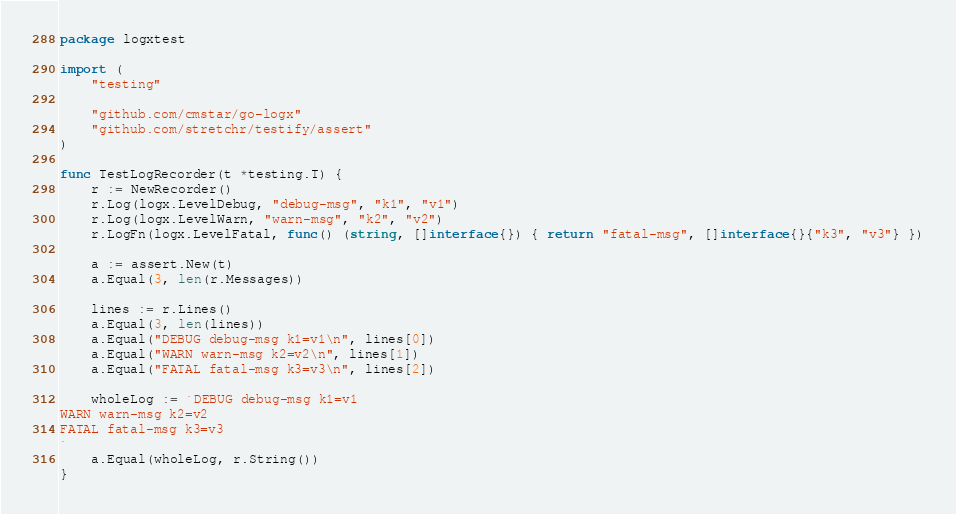<code> <loc_0><loc_0><loc_500><loc_500><_Go_>package logxtest

import (
	"testing"

	"github.com/cmstar/go-logx"
	"github.com/stretchr/testify/assert"
)

func TestLogRecorder(t *testing.T) {
	r := NewRecorder()
	r.Log(logx.LevelDebug, "debug-msg", "k1", "v1")
	r.Log(logx.LevelWarn, "warn-msg", "k2", "v2")
	r.LogFn(logx.LevelFatal, func() (string, []interface{}) { return "fatal-msg", []interface{}{"k3", "v3"} })

	a := assert.New(t)
	a.Equal(3, len(r.Messages))

	lines := r.Lines()
	a.Equal(3, len(lines))
	a.Equal("DEBUG debug-msg k1=v1\n", lines[0])
	a.Equal("WARN warn-msg k2=v2\n", lines[1])
	a.Equal("FATAL fatal-msg k3=v3\n", lines[2])

	wholeLog := `DEBUG debug-msg k1=v1
WARN warn-msg k2=v2
FATAL fatal-msg k3=v3
`
	a.Equal(wholeLog, r.String())
}
</code> 